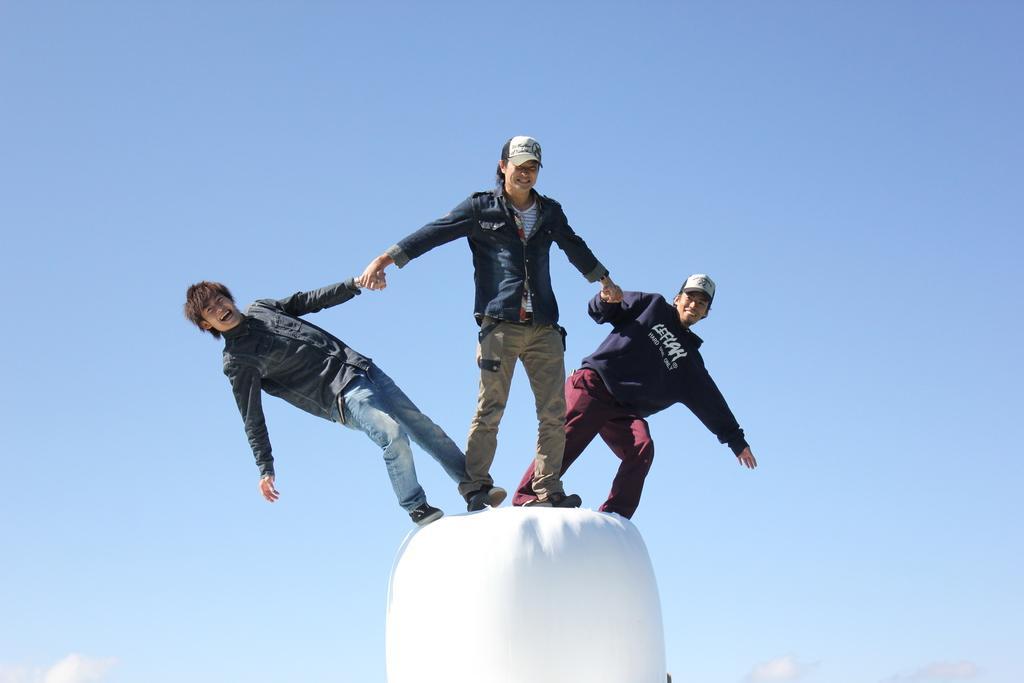Could you give a brief overview of what you see in this image? In the middle of the image we can see three people, few people wore caps, and they are smiling. 